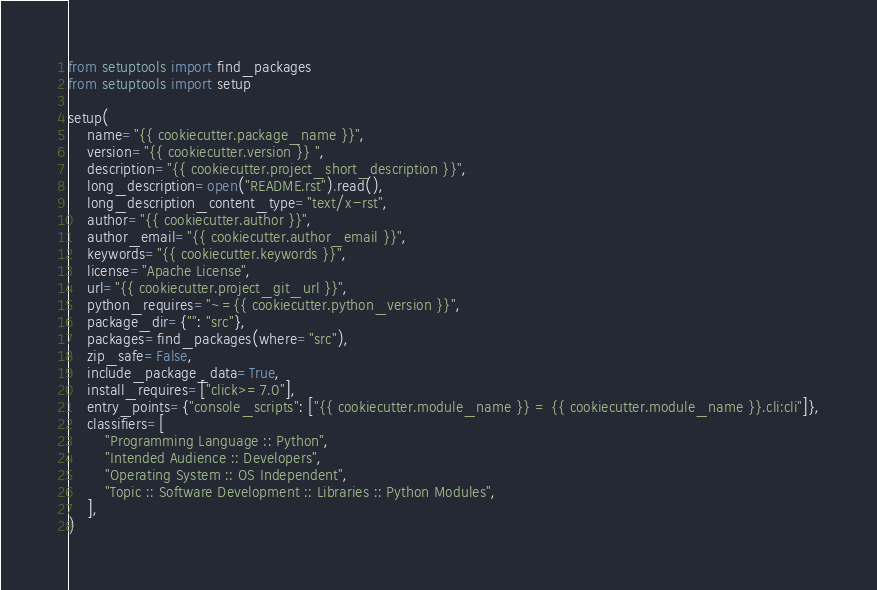Convert code to text. <code><loc_0><loc_0><loc_500><loc_500><_Python_>from setuptools import find_packages
from setuptools import setup

setup(
    name="{{ cookiecutter.package_name }}",
    version="{{ cookiecutter.version }} ",
    description="{{ cookiecutter.project_short_description }}",
    long_description=open("README.rst").read(),
    long_description_content_type="text/x-rst",
    author="{{ cookiecutter.author }}",
    author_email="{{ cookiecutter.author_email }}",
    keywords="{{ cookiecutter.keywords }}",
    license="Apache License",
    url="{{ cookiecutter.project_git_url }}",
    python_requires="~={{ cookiecutter.python_version }}",
    package_dir={"": "src"},
    packages=find_packages(where="src"),
    zip_safe=False,
    include_package_data=True,
    install_requires=["click>=7.0"],
    entry_points={"console_scripts": ["{{ cookiecutter.module_name }} = {{ cookiecutter.module_name }}.cli:cli"]},
    classifiers=[
        "Programming Language :: Python",
        "Intended Audience :: Developers",
        "Operating System :: OS Independent",
        "Topic :: Software Development :: Libraries :: Python Modules",
    ],
)
</code> 